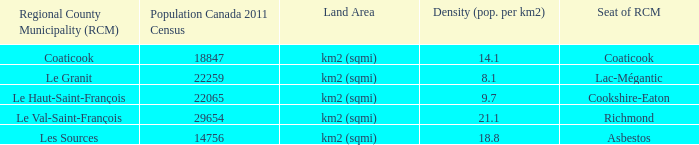7 density? Cookshire-Eaton. 